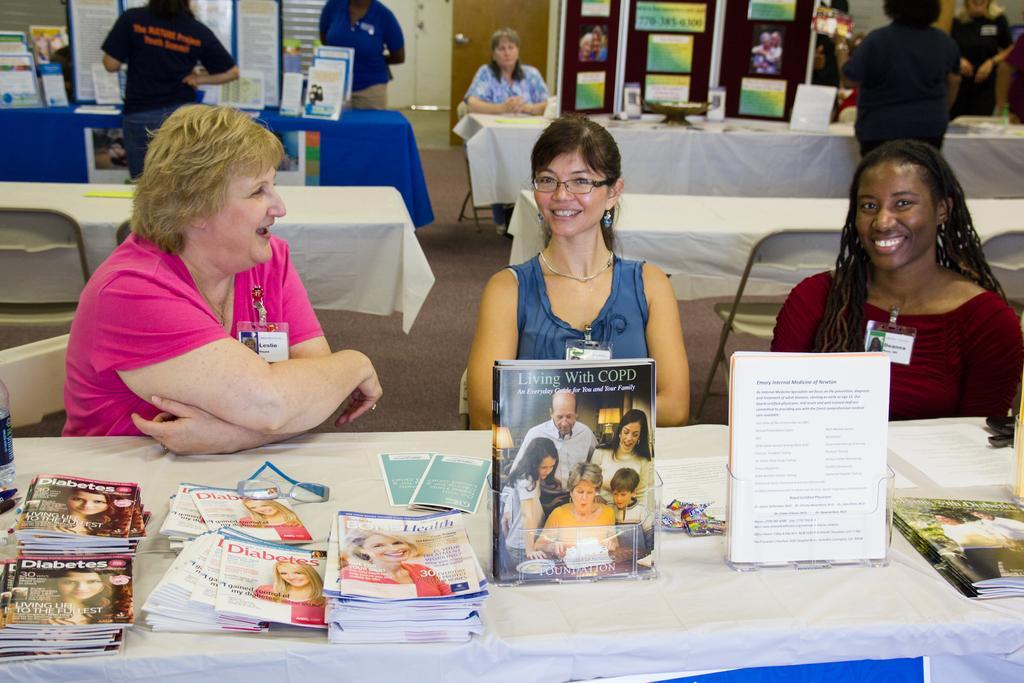How would you summarize this image in a sentence or two? In this image there are a group of people some of them are sitting and some of them are standing and also we could see some tables. On the tables there are some books and also chairs, in the background there are some boards, door and some other objects. At the bottom there is floor. 